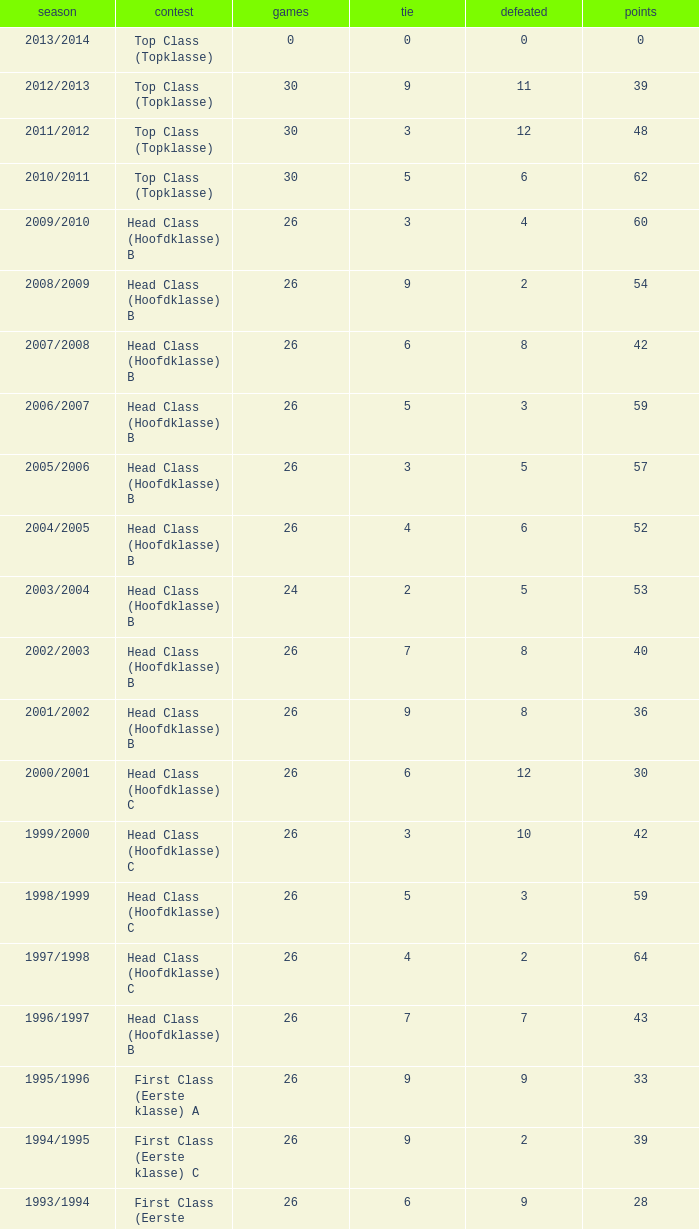What competition has a score greater than 30, a draw less than 5, and a loss larger than 10? Top Class (Topklasse). 